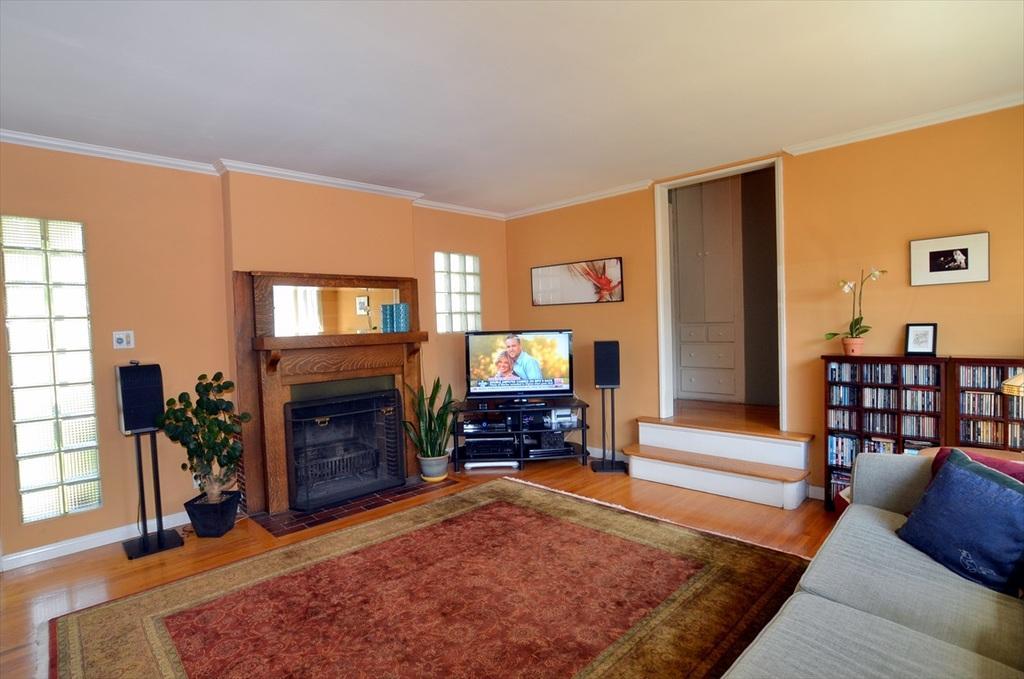How would you summarize this image in a sentence or two? This picture is taken in a room. There is a table having a television on it. Beside there is a sound speaker attached to the stand. There is a mirror attached to the wall. Before it there is a shelf having a bottle on it. There are pots having plants in it.. Right side there is a sofa having cushions in it. Beside there is a rack having books in it. There is a pot and a frame are on top of the rack. Pot of having a plant with flowers. Few picture frames are attached to the wall having a door. Before is there are stairs. Left side there is a window. Beside there is a sound speaker attached to a stand. 